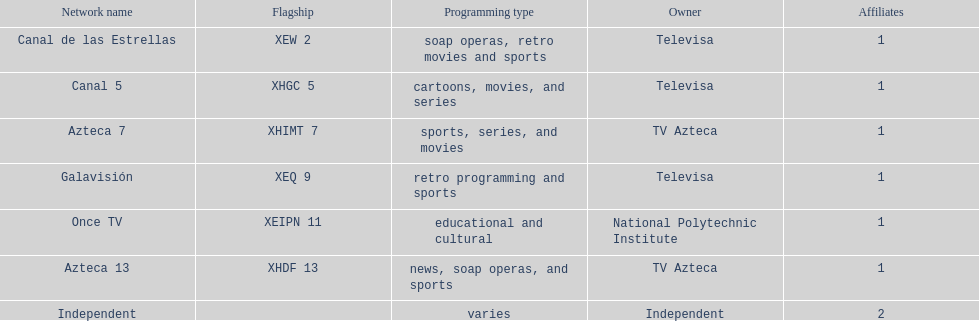What is the typical amount of affiliates a specific network possesses? 1. 